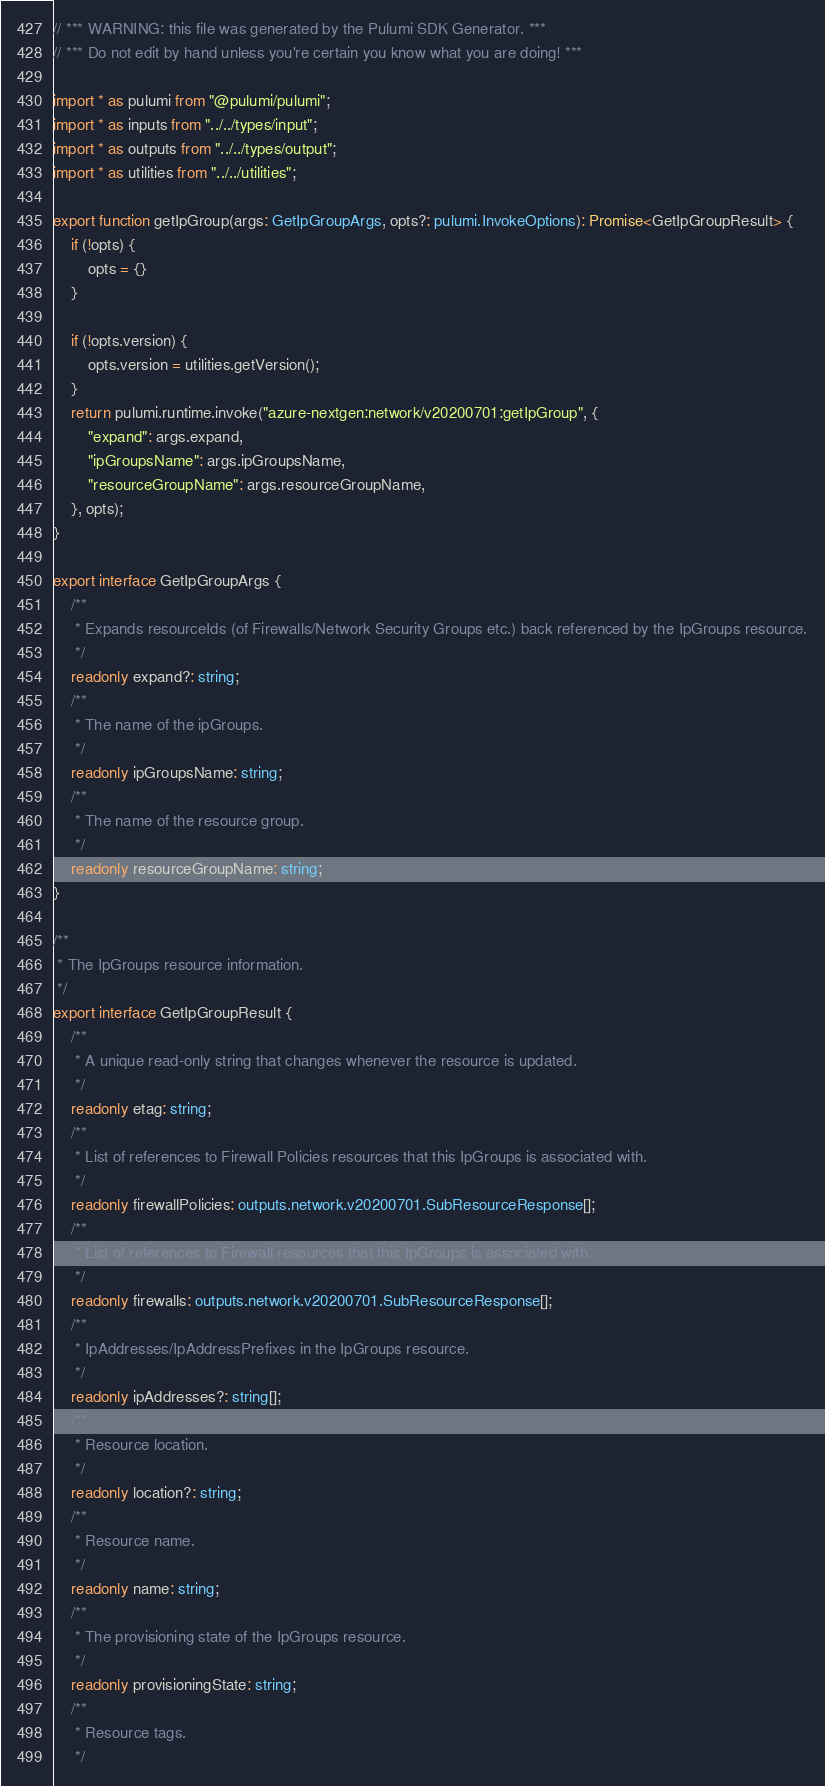<code> <loc_0><loc_0><loc_500><loc_500><_TypeScript_>// *** WARNING: this file was generated by the Pulumi SDK Generator. ***
// *** Do not edit by hand unless you're certain you know what you are doing! ***

import * as pulumi from "@pulumi/pulumi";
import * as inputs from "../../types/input";
import * as outputs from "../../types/output";
import * as utilities from "../../utilities";

export function getIpGroup(args: GetIpGroupArgs, opts?: pulumi.InvokeOptions): Promise<GetIpGroupResult> {
    if (!opts) {
        opts = {}
    }

    if (!opts.version) {
        opts.version = utilities.getVersion();
    }
    return pulumi.runtime.invoke("azure-nextgen:network/v20200701:getIpGroup", {
        "expand": args.expand,
        "ipGroupsName": args.ipGroupsName,
        "resourceGroupName": args.resourceGroupName,
    }, opts);
}

export interface GetIpGroupArgs {
    /**
     * Expands resourceIds (of Firewalls/Network Security Groups etc.) back referenced by the IpGroups resource.
     */
    readonly expand?: string;
    /**
     * The name of the ipGroups.
     */
    readonly ipGroupsName: string;
    /**
     * The name of the resource group.
     */
    readonly resourceGroupName: string;
}

/**
 * The IpGroups resource information.
 */
export interface GetIpGroupResult {
    /**
     * A unique read-only string that changes whenever the resource is updated.
     */
    readonly etag: string;
    /**
     * List of references to Firewall Policies resources that this IpGroups is associated with.
     */
    readonly firewallPolicies: outputs.network.v20200701.SubResourceResponse[];
    /**
     * List of references to Firewall resources that this IpGroups is associated with.
     */
    readonly firewalls: outputs.network.v20200701.SubResourceResponse[];
    /**
     * IpAddresses/IpAddressPrefixes in the IpGroups resource.
     */
    readonly ipAddresses?: string[];
    /**
     * Resource location.
     */
    readonly location?: string;
    /**
     * Resource name.
     */
    readonly name: string;
    /**
     * The provisioning state of the IpGroups resource.
     */
    readonly provisioningState: string;
    /**
     * Resource tags.
     */</code> 